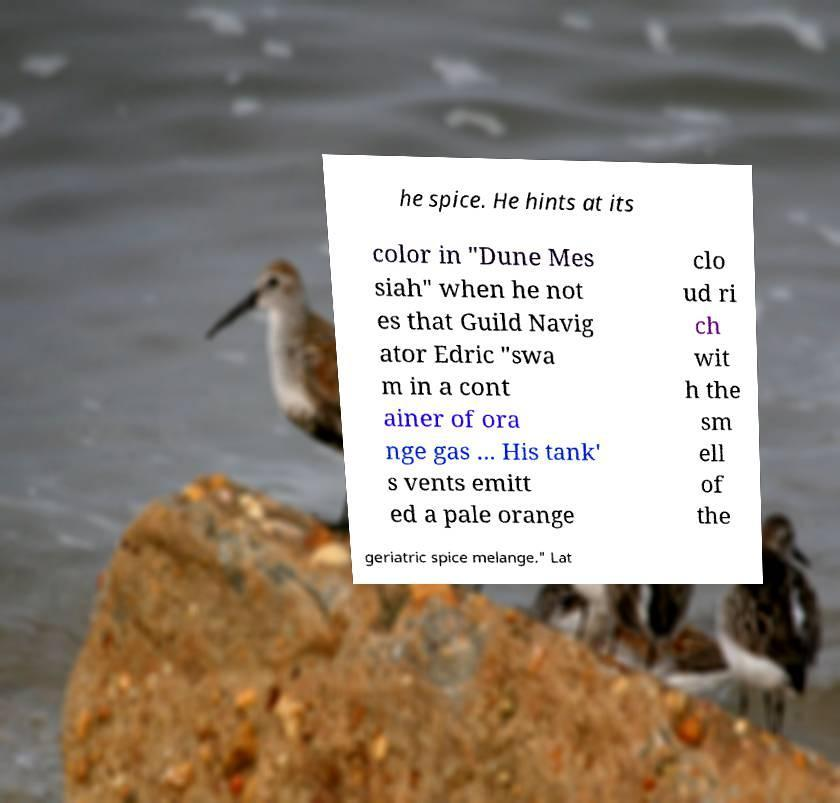Could you extract and type out the text from this image? he spice. He hints at its color in "Dune Mes siah" when he not es that Guild Navig ator Edric "swa m in a cont ainer of ora nge gas ... His tank' s vents emitt ed a pale orange clo ud ri ch wit h the sm ell of the geriatric spice melange." Lat 